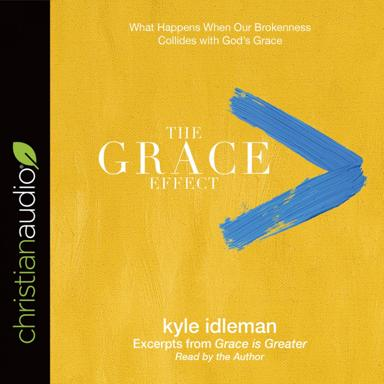How might the cover design of "The Grace Effect" audiobook relate to its content? The cover design of "The Grace Effect" audiobook features a stark contrast between the bright yellow background and the bold blue brushstroke, which may symbolize the light and hope grace brings into our lives amid chaos or darkness. The simplicity of the design also suggests a clear, accessible message within the book, emphasizing the pure and powerful effect grace can have. 